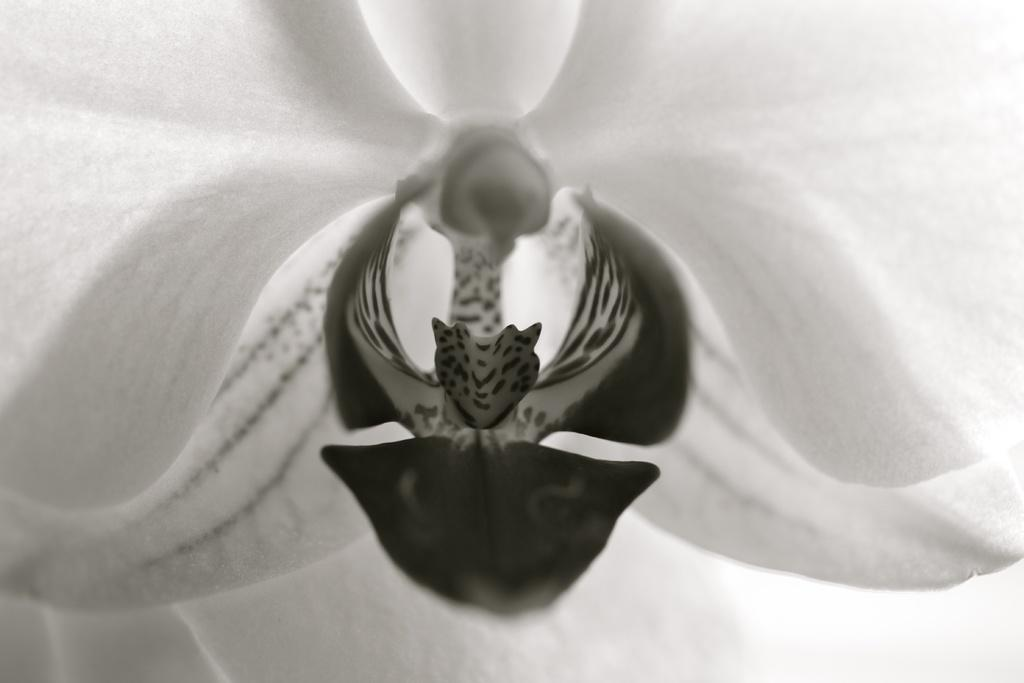What is the color scheme of the picture? The picture is black and white. What type of object can be seen in the picture? There is a flower in the picture. What type of dinner is being served in the image? There is no dinner present in the image; it features a black and white picture of a flower. What channel is the flower from in the image? The image is a still photograph and does not depict a channel or source. 